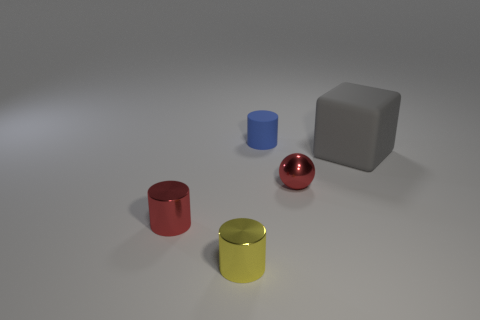Is there anything else that is the same size as the gray object?
Your response must be concise. No. What is the color of the metal ball that is the same size as the yellow shiny cylinder?
Offer a terse response. Red. What number of cylinders are big gray matte things or blue objects?
Give a very brief answer. 1. Do the gray rubber thing and the tiny red shiny thing that is right of the yellow shiny cylinder have the same shape?
Your response must be concise. No. How many matte objects are the same size as the yellow metal object?
Make the answer very short. 1. Do the rubber thing on the left side of the big gray cube and the tiny red shiny object on the left side of the small red shiny sphere have the same shape?
Keep it short and to the point. Yes. The tiny thing that is the same color as the sphere is what shape?
Your response must be concise. Cylinder. What is the color of the shiny object that is to the right of the tiny cylinder that is behind the gray cube?
Make the answer very short. Red. There is another small metal thing that is the same shape as the tiny yellow thing; what is its color?
Give a very brief answer. Red. There is a red shiny object that is the same shape as the blue thing; what is its size?
Provide a succinct answer. Small. 